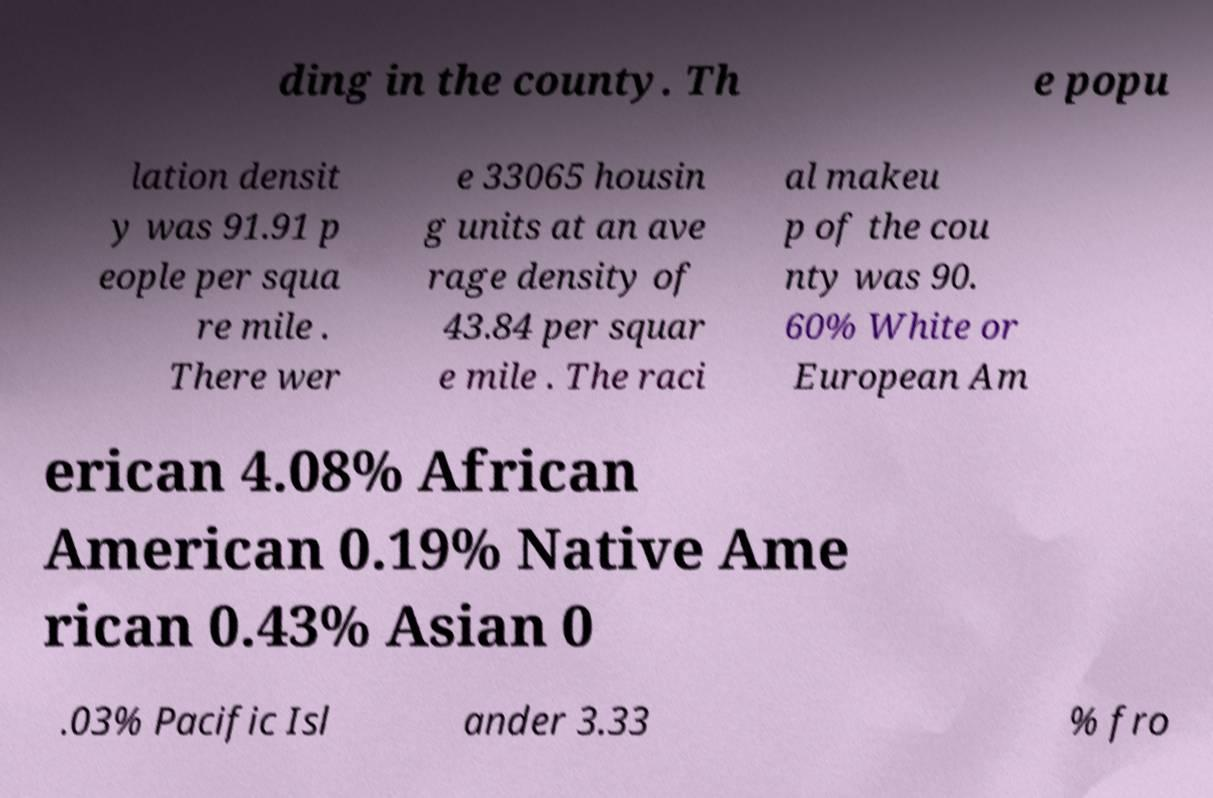What messages or text are displayed in this image? I need them in a readable, typed format. ding in the county. Th e popu lation densit y was 91.91 p eople per squa re mile . There wer e 33065 housin g units at an ave rage density of 43.84 per squar e mile . The raci al makeu p of the cou nty was 90. 60% White or European Am erican 4.08% African American 0.19% Native Ame rican 0.43% Asian 0 .03% Pacific Isl ander 3.33 % fro 